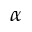<formula> <loc_0><loc_0><loc_500><loc_500>\alpha</formula> 